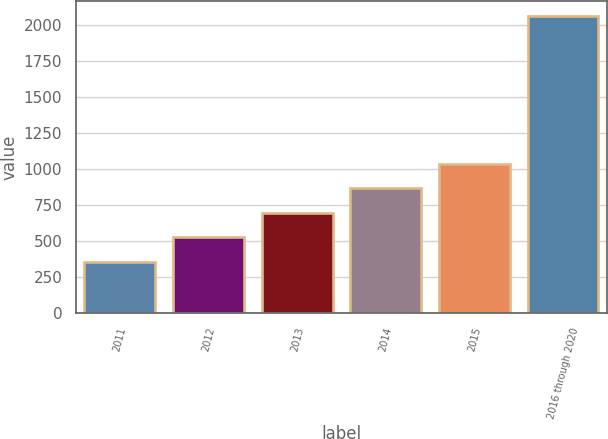Convert chart to OTSL. <chart><loc_0><loc_0><loc_500><loc_500><bar_chart><fcel>2011<fcel>2012<fcel>2013<fcel>2014<fcel>2015<fcel>2016 through 2020<nl><fcel>355<fcel>525.6<fcel>696.2<fcel>866.8<fcel>1037.4<fcel>2061<nl></chart> 